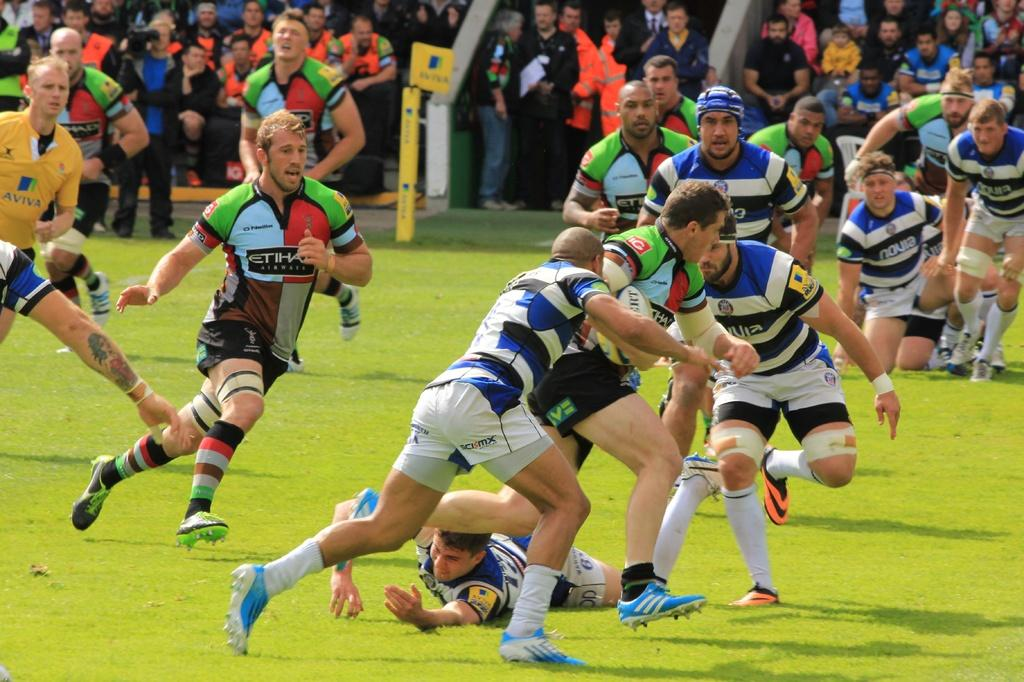<image>
Describe the image concisely. some players and one with an Etihal word on it 